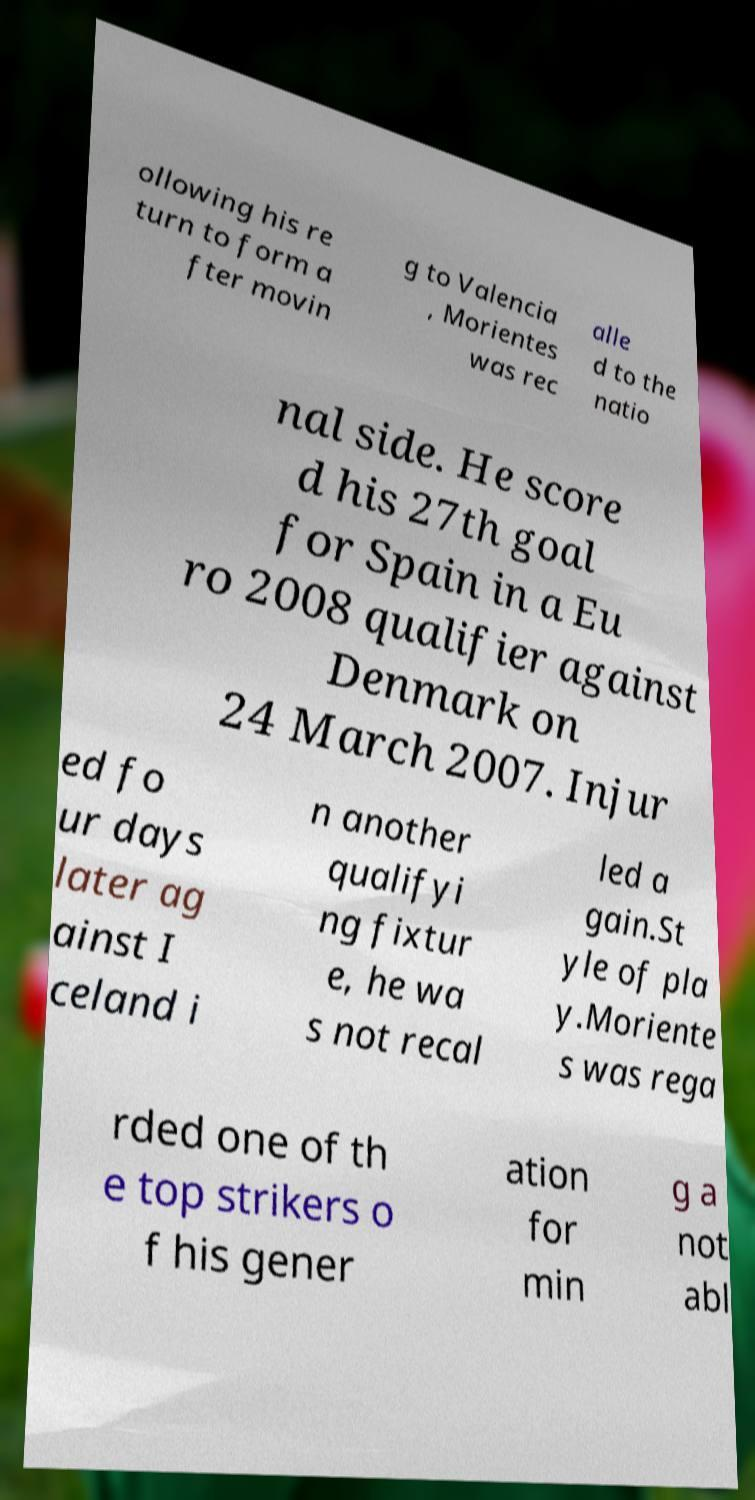Can you read and provide the text displayed in the image?This photo seems to have some interesting text. Can you extract and type it out for me? ollowing his re turn to form a fter movin g to Valencia , Morientes was rec alle d to the natio nal side. He score d his 27th goal for Spain in a Eu ro 2008 qualifier against Denmark on 24 March 2007. Injur ed fo ur days later ag ainst I celand i n another qualifyi ng fixtur e, he wa s not recal led a gain.St yle of pla y.Moriente s was rega rded one of th e top strikers o f his gener ation for min g a not abl 